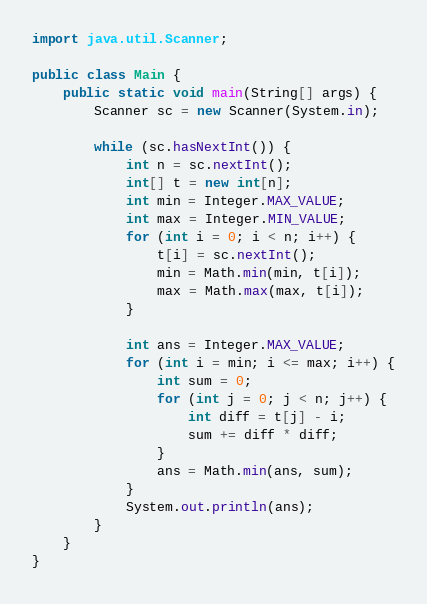Convert code to text. <code><loc_0><loc_0><loc_500><loc_500><_Java_>

import java.util.Scanner;

public class Main {
    public static void main(String[] args) {
        Scanner sc = new Scanner(System.in);

        while (sc.hasNextInt()) {
            int n = sc.nextInt();
            int[] t = new int[n];
            int min = Integer.MAX_VALUE;
            int max = Integer.MIN_VALUE;
            for (int i = 0; i < n; i++) {
                t[i] = sc.nextInt();
                min = Math.min(min, t[i]);
                max = Math.max(max, t[i]);
            }

            int ans = Integer.MAX_VALUE;
            for (int i = min; i <= max; i++) {
                int sum = 0;
                for (int j = 0; j < n; j++) {
                    int diff = t[j] - i;
                    sum += diff * diff;
                }
                ans = Math.min(ans, sum);
            }
            System.out.println(ans);
        }
    }
}
</code> 